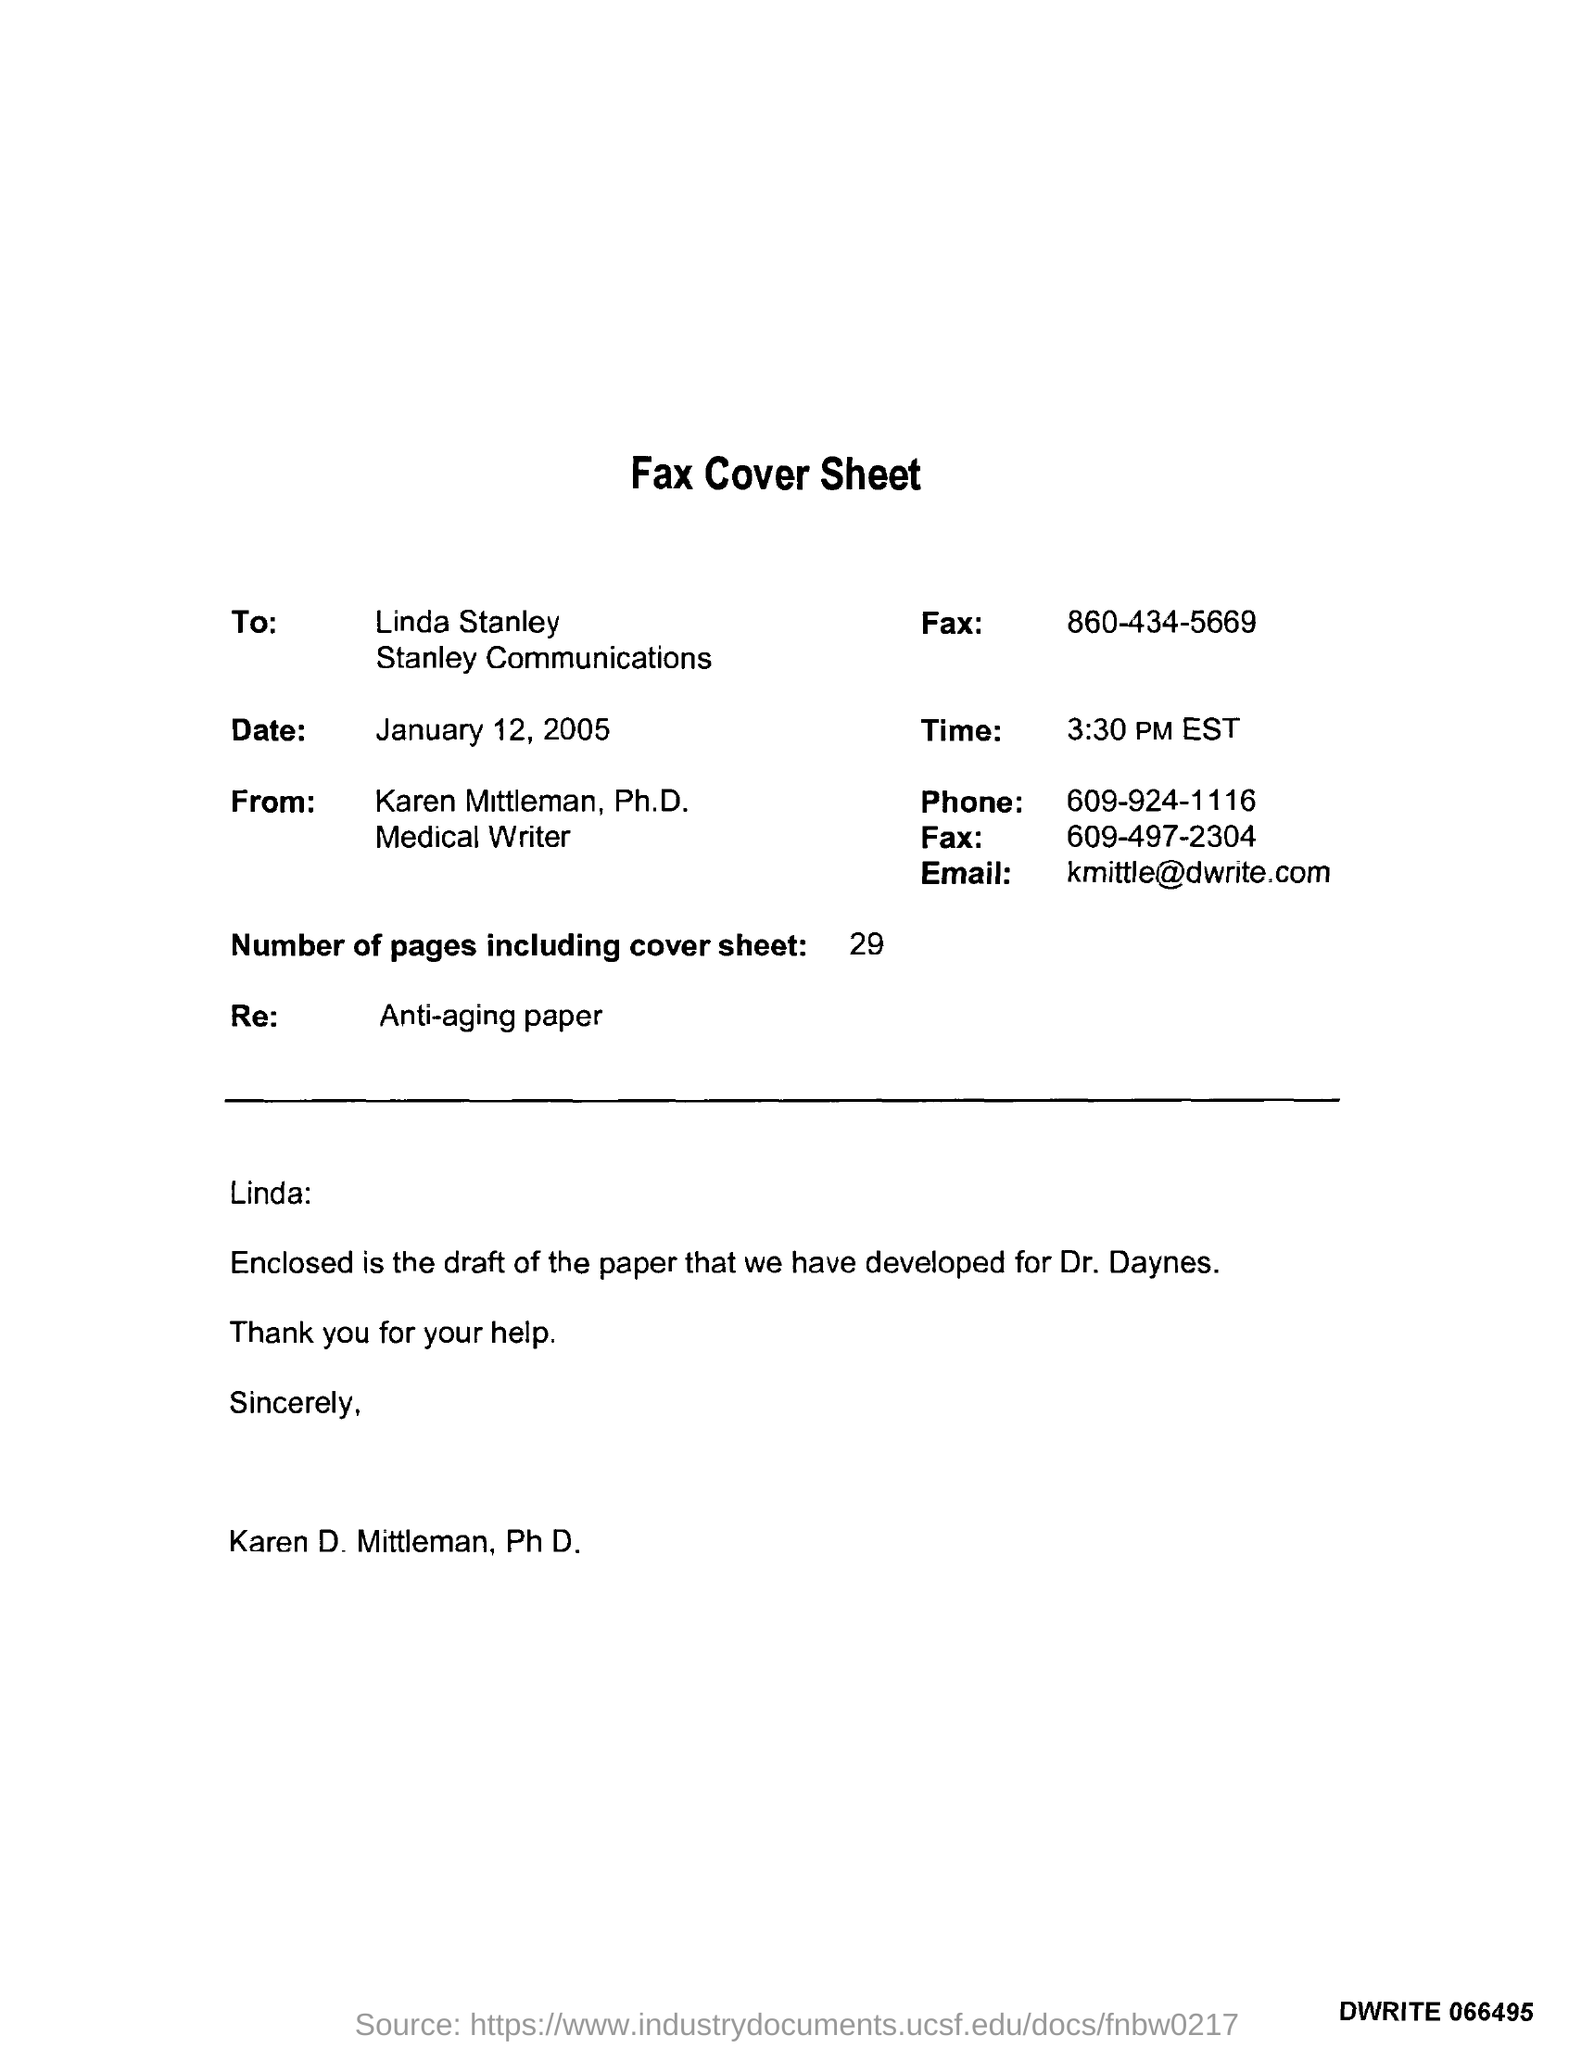List a handful of essential elements in this visual. The time mentioned in the given fax cover sheet is 3:30 PM EST. The "RE" referred to in the fax cover sheet is "Anti-aging paper. The letter was written to Linda Stanley. The recipient of this fax message is Karen Mittleman, Ph.D. There are 29 pages in total, including the cover sheet. 